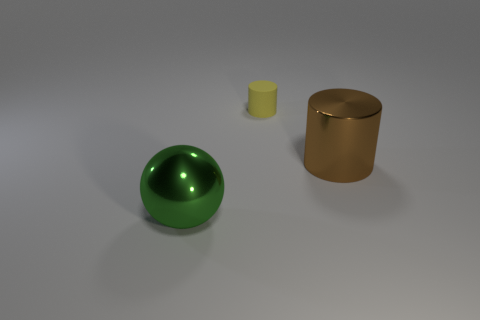There is a brown metallic thing in front of the tiny matte cylinder; is it the same shape as the large metal thing that is to the left of the large brown shiny thing?
Make the answer very short. No. What is the shape of the brown metal thing that is the same size as the green ball?
Make the answer very short. Cylinder. Are there an equal number of brown cylinders that are behind the tiny object and tiny yellow cylinders in front of the green metal sphere?
Your answer should be compact. Yes. Are there any other things that have the same shape as the brown object?
Make the answer very short. Yes. Does the object on the right side of the tiny yellow rubber thing have the same material as the big green sphere?
Ensure brevity in your answer.  Yes. There is a cylinder that is the same size as the green shiny object; what is its material?
Your response must be concise. Metal. What number of other things are the same material as the tiny yellow thing?
Provide a short and direct response. 0. There is a green sphere; does it have the same size as the cylinder that is on the left side of the large brown cylinder?
Your answer should be compact. No. Are there fewer metallic things on the left side of the rubber object than cylinders that are on the left side of the big brown shiny cylinder?
Provide a short and direct response. No. There is a shiny object that is on the right side of the big green object; what size is it?
Offer a terse response. Large. 